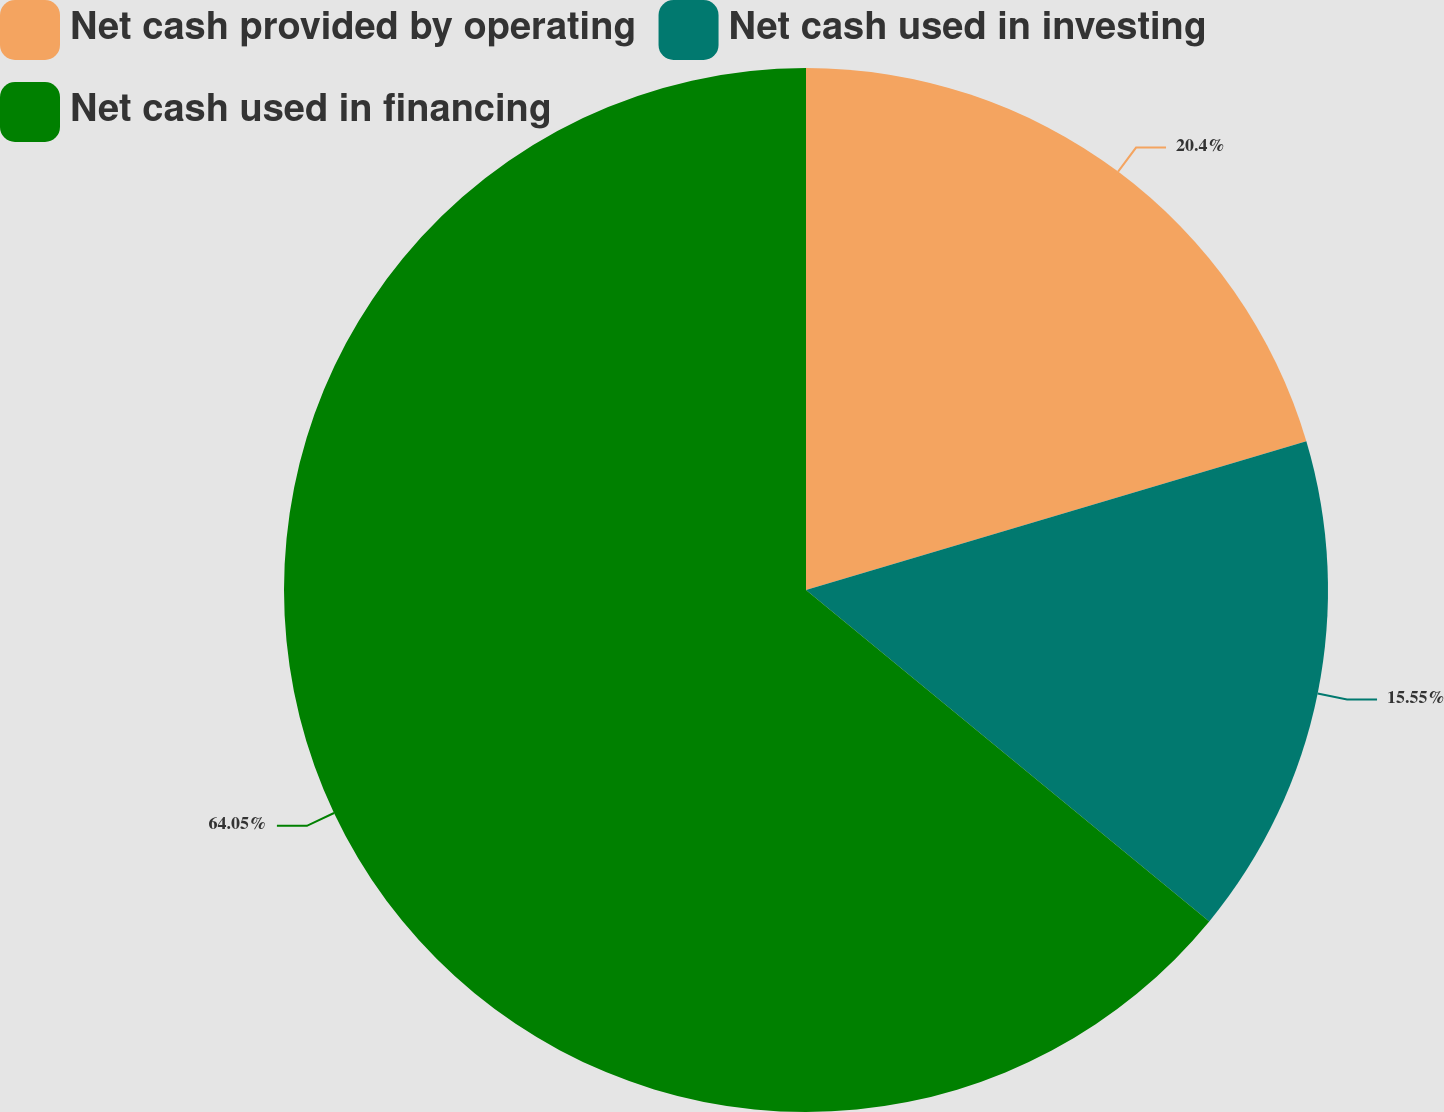<chart> <loc_0><loc_0><loc_500><loc_500><pie_chart><fcel>Net cash provided by operating<fcel>Net cash used in investing<fcel>Net cash used in financing<nl><fcel>20.4%<fcel>15.55%<fcel>64.05%<nl></chart> 